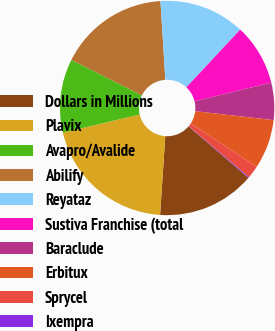<chart> <loc_0><loc_0><loc_500><loc_500><pie_chart><fcel>Dollars in Millions<fcel>Plavix<fcel>Avapro/Avalide<fcel>Abilify<fcel>Reyataz<fcel>Sustiva Franchise (total<fcel>Baraclude<fcel>Erbitux<fcel>Sprycel<fcel>Ixempra<nl><fcel>14.76%<fcel>20.26%<fcel>11.1%<fcel>16.6%<fcel>12.93%<fcel>9.27%<fcel>5.6%<fcel>7.43%<fcel>1.94%<fcel>0.11%<nl></chart> 